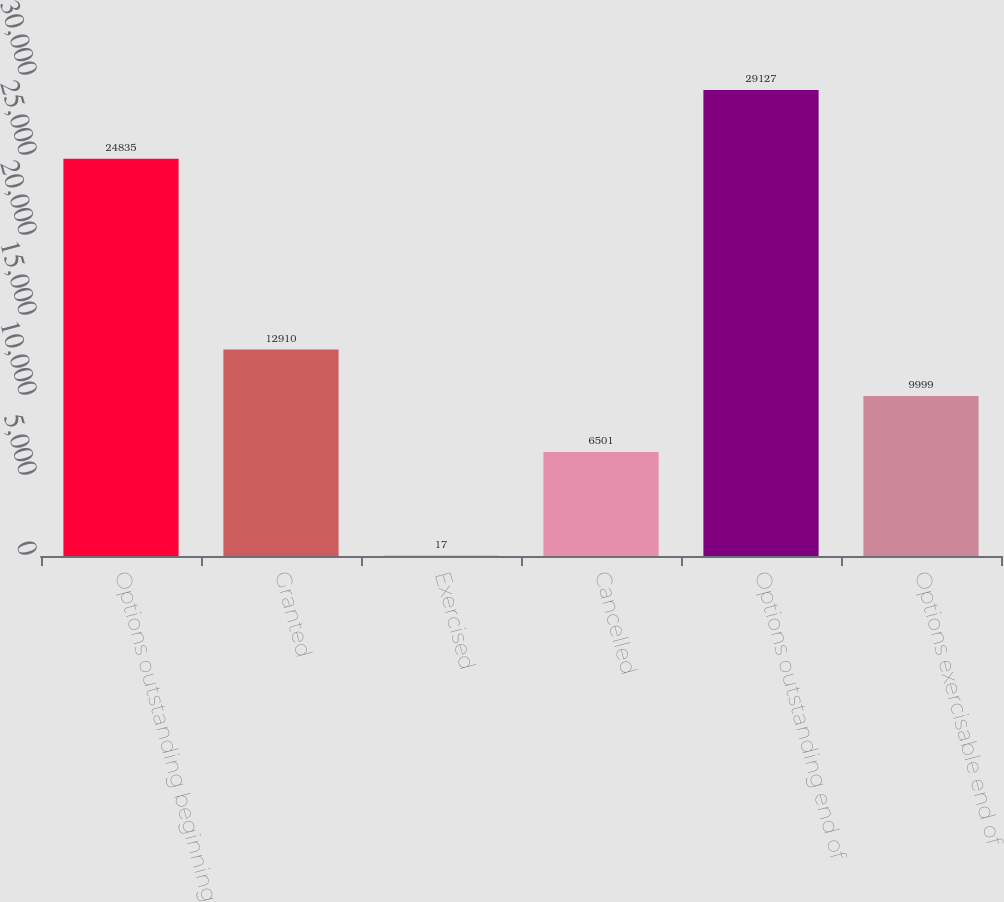Convert chart to OTSL. <chart><loc_0><loc_0><loc_500><loc_500><bar_chart><fcel>Options outstanding beginning<fcel>Granted<fcel>Exercised<fcel>Cancelled<fcel>Options outstanding end of<fcel>Options exercisable end of<nl><fcel>24835<fcel>12910<fcel>17<fcel>6501<fcel>29127<fcel>9999<nl></chart> 